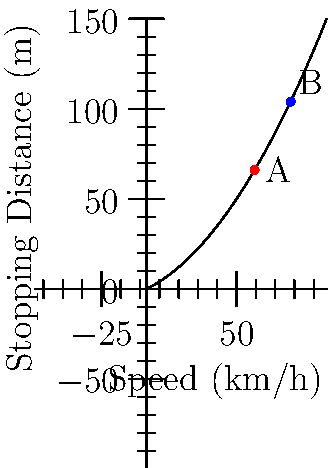Based on the graph showing the relationship between vehicle speed and stopping distance on a dry road, estimate the difference in stopping distance between a vehicle traveling at 60 km/h (point A) and one traveling at 80 km/h (point B). Let's approach this step-by-step:

1) First, we need to estimate the stopping distances for both speeds:
   - At 60 km/h (point A), the stopping distance appears to be about 45 meters
   - At 80 km/h (point B), the stopping distance appears to be about 75 meters

2) To find the difference, we subtract:
   $75 m - 45 m = 30 m$

3) This result aligns with the general rule we used in the Ufa Traffic Safety Department:
   The stopping distance approximately quadruples when the speed doubles.

4) We can verify this using the formula:
   $Stopping Distance \approx 0.01v^2 + 0.5v$ (where v is speed in km/h)

   For 60 km/h: $0.01(60)^2 + 0.5(60) = 36 + 30 = 66 m$
   For 80 km/h: $0.01(80)^2 + 0.5(80) = 64 + 40 = 104 m$

   The difference: $104 m - 66 m = 38 m$

5) Our estimate of 30 m is reasonably close to the calculated 38 m, considering the graph's scale and potential reading errors.
Answer: Approximately 30 meters 